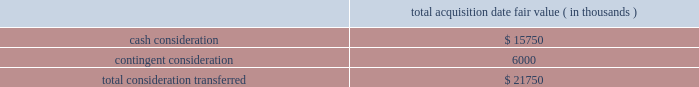Abiomed , inc .
And subsidiaries notes to consolidated financial statements 2014 ( continued ) note 3 .
Acquisitions ( continued ) including the revenues of third-party licensees , or ( ii ) the company 2019s sale of ( a ) ecp , ( b ) all or substantially all of ecp 2019s assets , or ( c ) certain of ecp 2019s patent rights , the company will pay to syscore the lesser of ( x ) one-half of the profits earned from such sale described in the foregoing item ( ii ) , after accounting for the costs of acquiring and operating ecp , or ( y ) $ 15.0 million ( less any previous milestone payment ) .
Ecp 2019s acquisition of ais gmbh aachen innovative solutions in connection with the company 2019s acquisition of ecp , ecp acquired all of the share capital of ais gmbh aachen innovative solutions ( 201cais 201d ) , a limited liability company incorporated in germany , pursuant to a share purchase agreement dated as of june 30 , 2014 , by and among ecp and ais 2019s four individual shareholders .
Ais , based in aachen , germany , holds certain intellectual property useful to ecp 2019s business , and , prior to being acquired by ecp , had licensed such intellectual property to ecp .
The purchase price for the acquisition of ais 2019s share capital was approximately $ 2.8 million in cash , which was provided by the company , and the acquisition closed immediately prior to abiomed europe 2019s acquisition of ecp .
The share purchase agreement contains representations , warranties and closing conditions customary for transactions of its size and nature .
Purchase price allocation the acquisition of ecp and ais was accounted for as a business combination .
The purchase price for the acquisition has been allocated to the assets acquired and liabilities assumed based on their estimated fair values .
The acquisition-date fair value of the consideration transferred is as follows : acquisition date fair value ( in thousands ) .

What portion of total consideration transferred for acquisition of ecp and ais is cash consideration? 
Computations: (15750 / 21750)
Answer: 0.72414. 